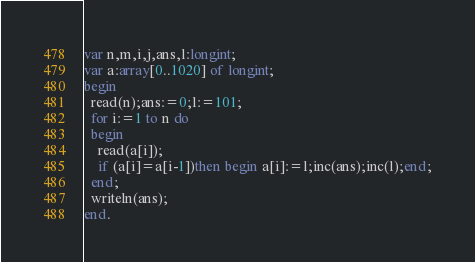Convert code to text. <code><loc_0><loc_0><loc_500><loc_500><_Pascal_>var n,m,i,j,ans,l:longint;
var a:array[0..1020] of longint;
begin
  read(n);ans:=0;l:=101;
  for i:=1 to n do
  begin
    read(a[i]);
    if (a[i]=a[i-1])then begin a[i]:=l;inc(ans);inc(l);end;
  end;
  writeln(ans);
end.</code> 